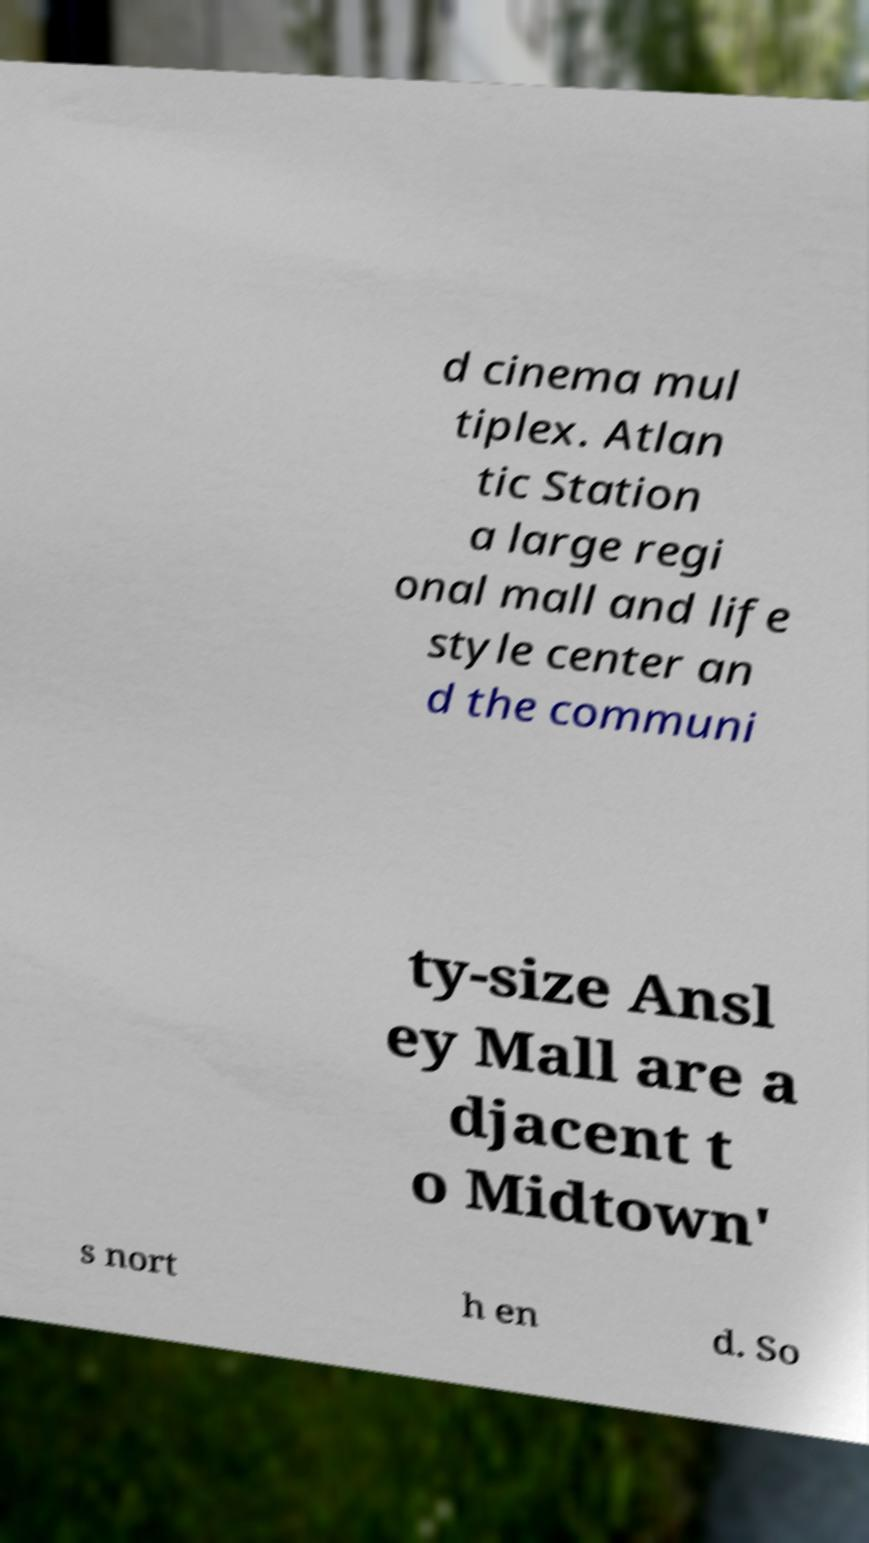What messages or text are displayed in this image? I need them in a readable, typed format. d cinema mul tiplex. Atlan tic Station a large regi onal mall and life style center an d the communi ty-size Ansl ey Mall are a djacent t o Midtown' s nort h en d. So 